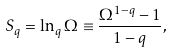Convert formula to latex. <formula><loc_0><loc_0><loc_500><loc_500>S _ { q } = \ln _ { q } \Omega \equiv \frac { \Omega ^ { 1 - q } - 1 } { 1 - q } ,</formula> 